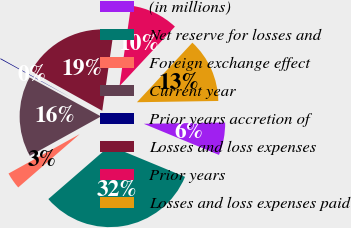Convert chart. <chart><loc_0><loc_0><loc_500><loc_500><pie_chart><fcel>(in millions)<fcel>Net reserve for losses and<fcel>Foreign exchange effect<fcel>Current year<fcel>Prior years accretion of<fcel>Losses and loss expenses<fcel>Prior years<fcel>Losses and loss expenses paid<nl><fcel>6.49%<fcel>32.39%<fcel>3.32%<fcel>16.0%<fcel>0.15%<fcel>19.17%<fcel>9.66%<fcel>12.83%<nl></chart> 